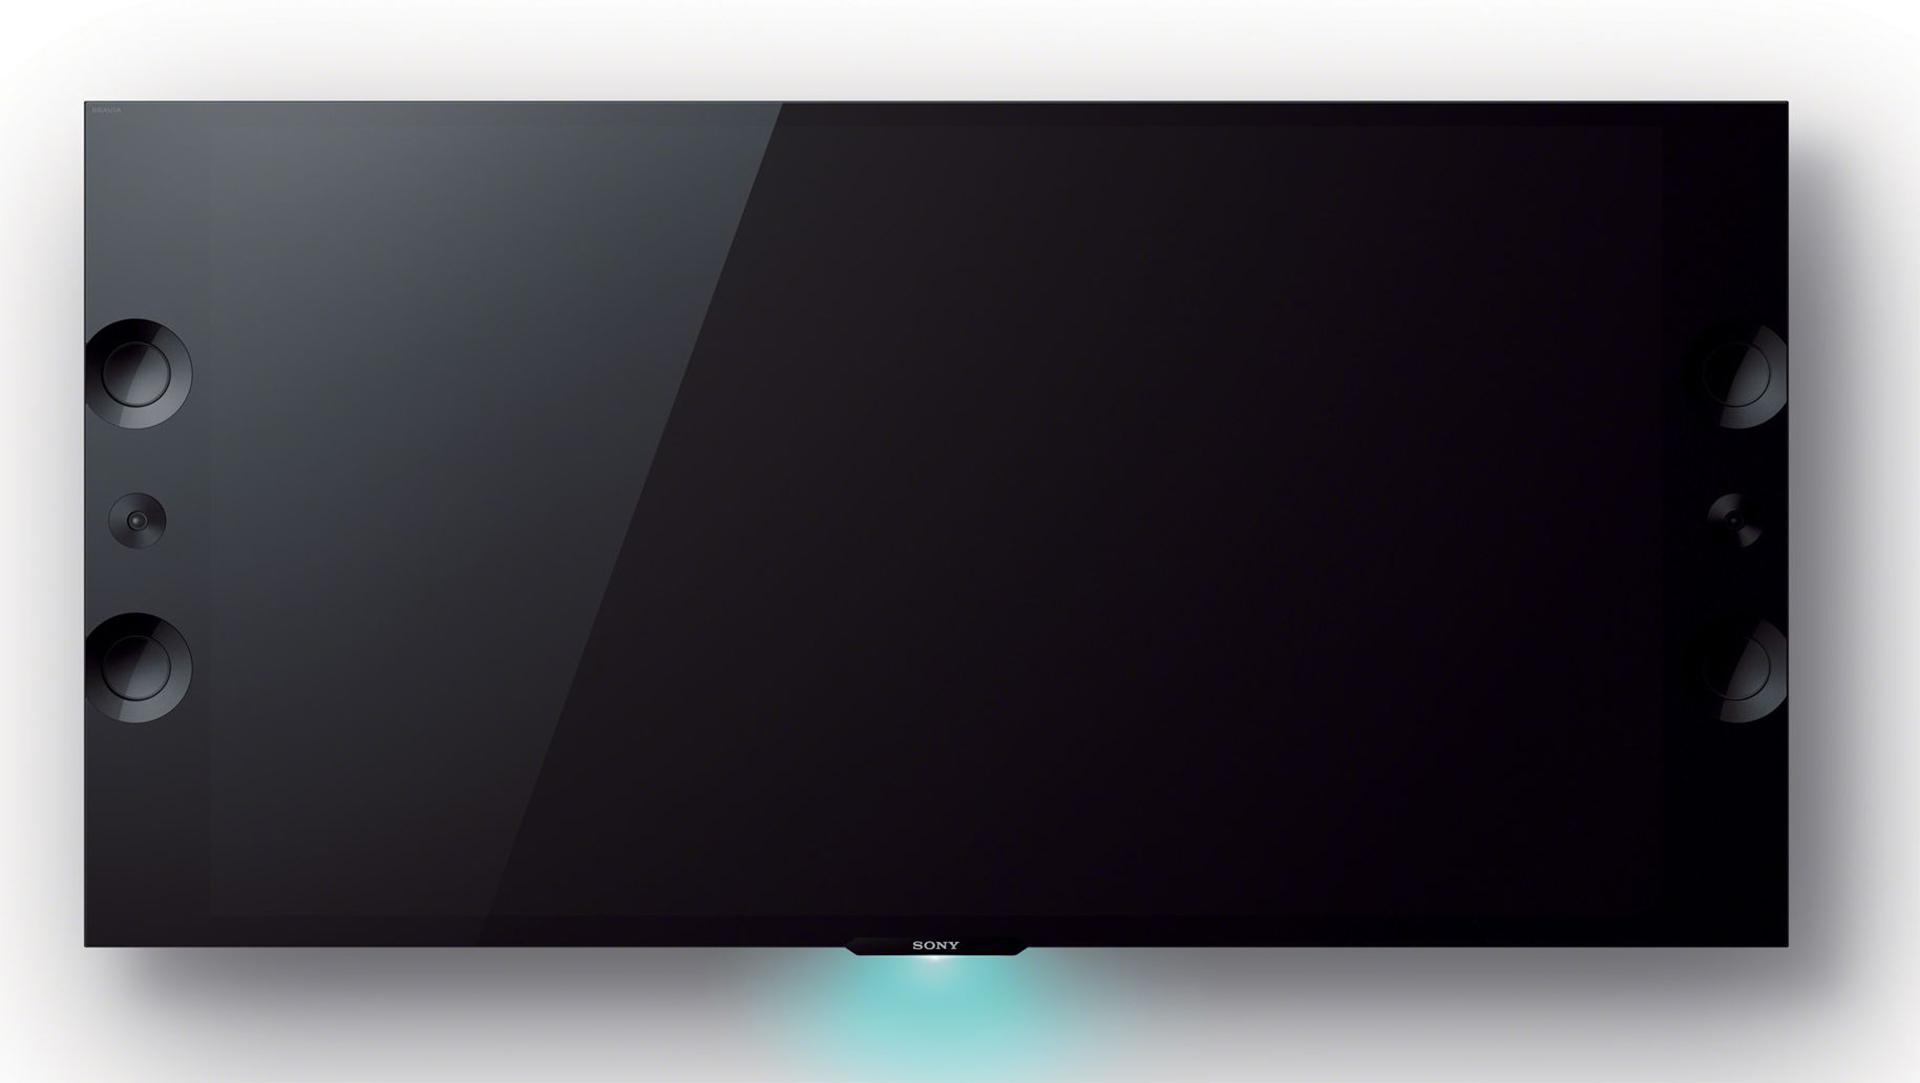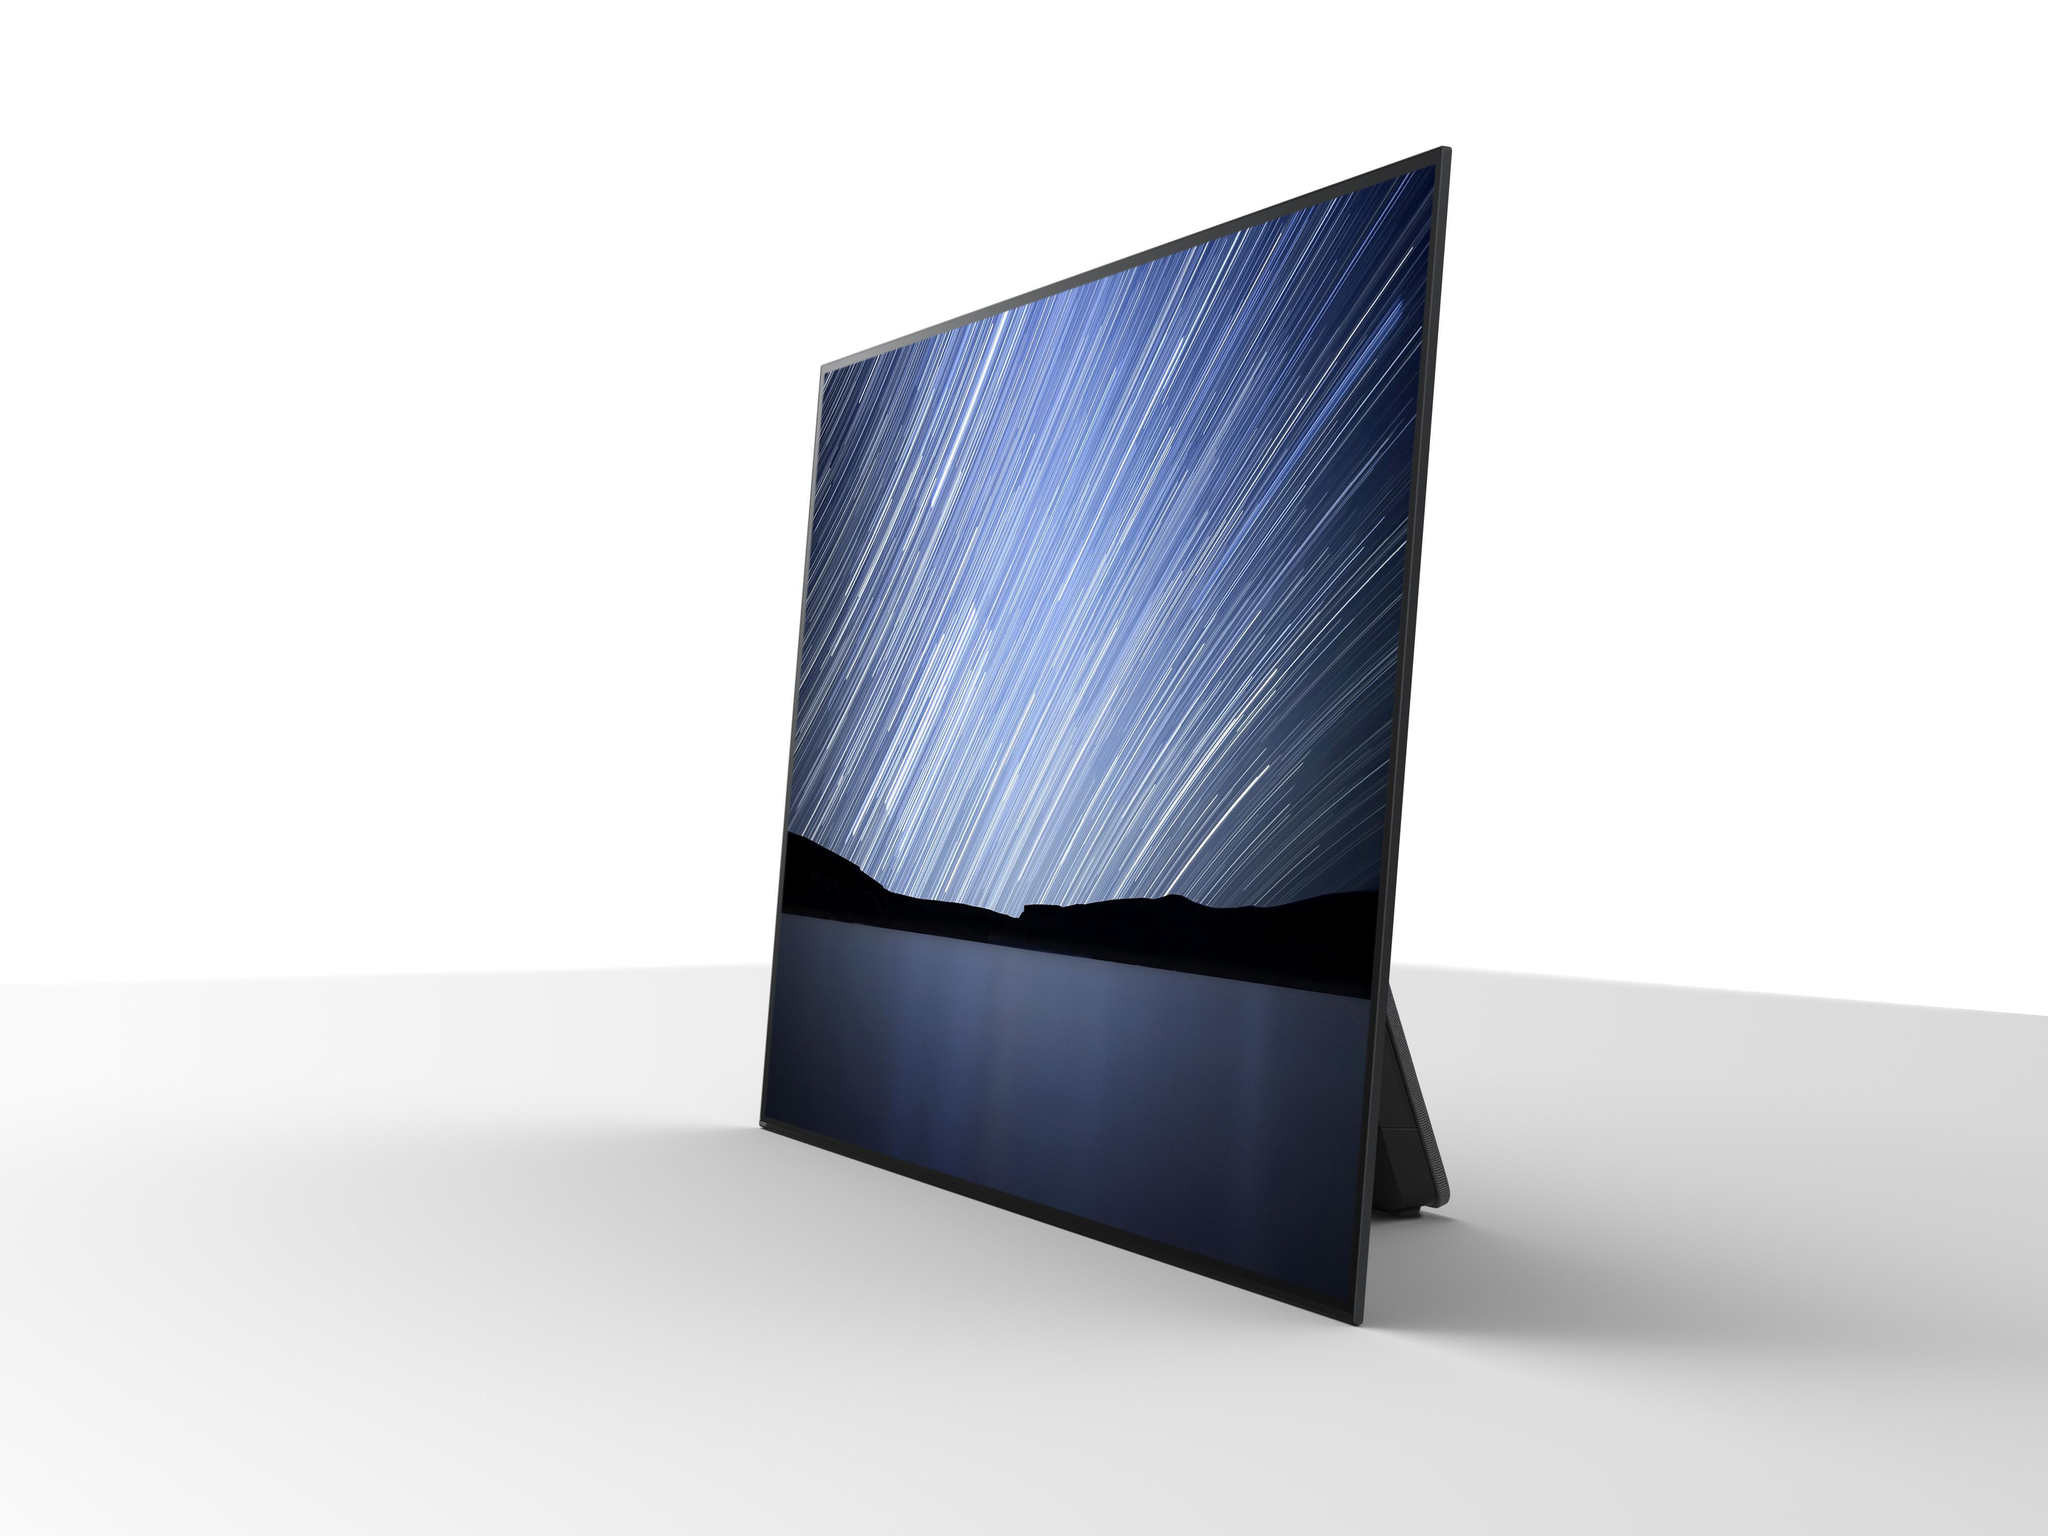The first image is the image on the left, the second image is the image on the right. For the images shown, is this caption "Each image shows one black-screened TV elevated by chrome legs." true? Answer yes or no. No. 